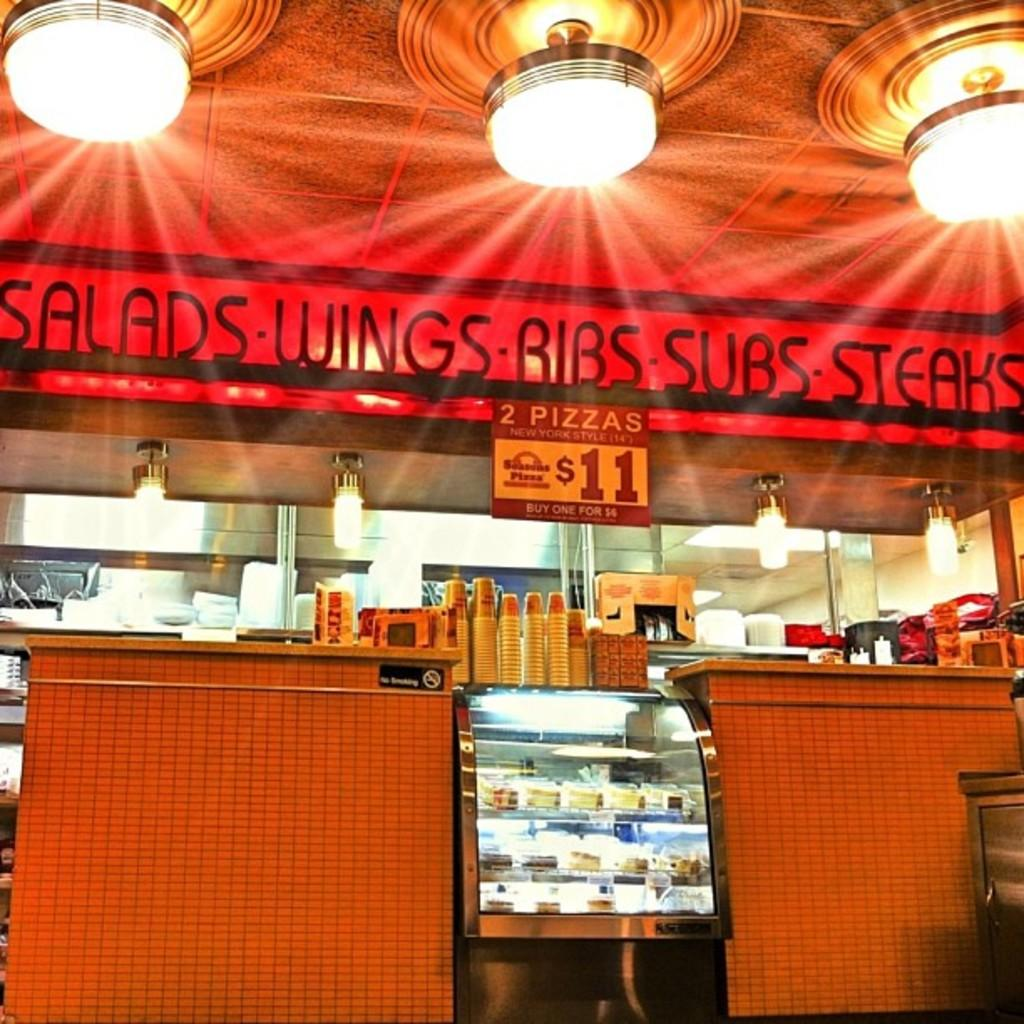<image>
Create a compact narrative representing the image presented. A restaurant that cells salads, wings, ribs, subs, and steaks 